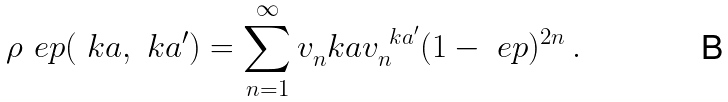Convert formula to latex. <formula><loc_0><loc_0><loc_500><loc_500>\rho _ { \ } e p ( \ k a , \ k a ^ { \prime } ) = \sum _ { n = 1 } ^ { \infty } v _ { n } ^ { \ } k a v _ { n } ^ { \ k a ^ { \prime } } ( 1 - \ e p ) ^ { 2 n } \, .</formula> 